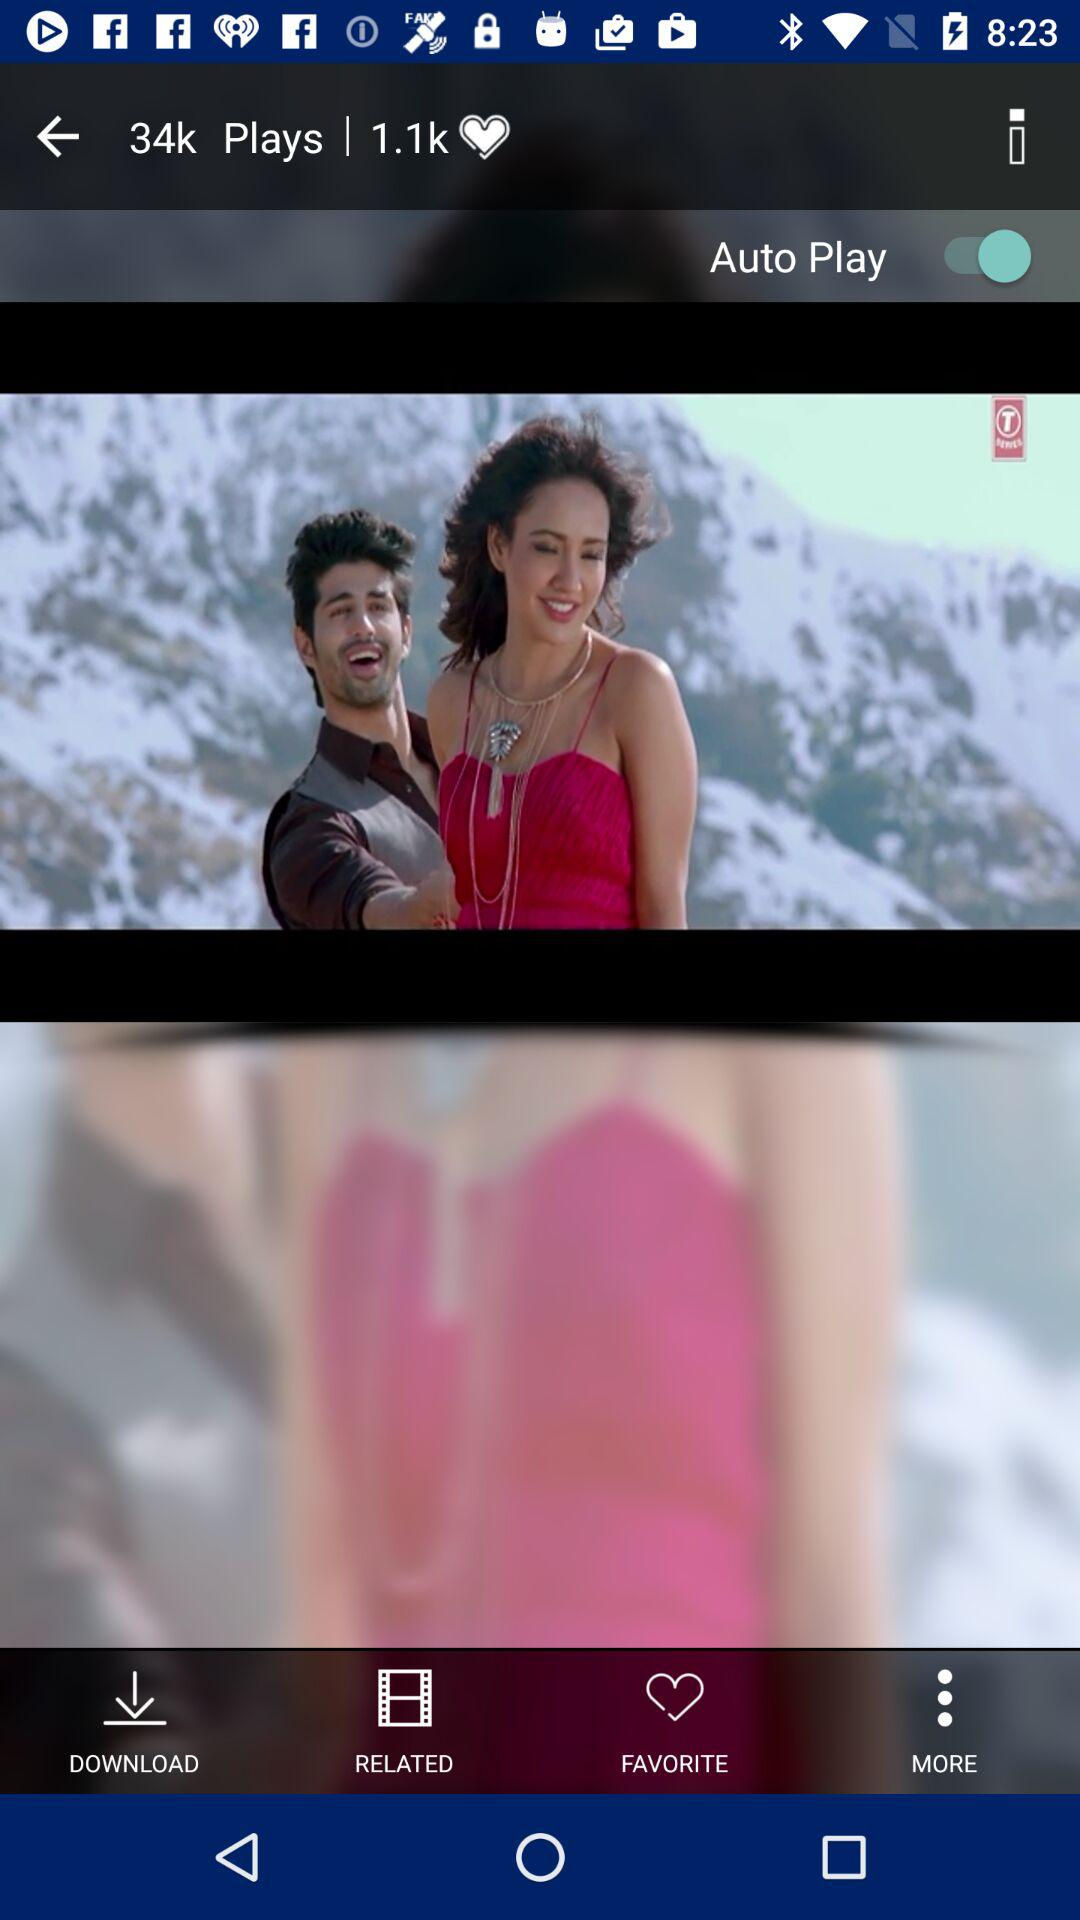How many videos were downloaded?
When the provided information is insufficient, respond with <no answer>. <no answer> 